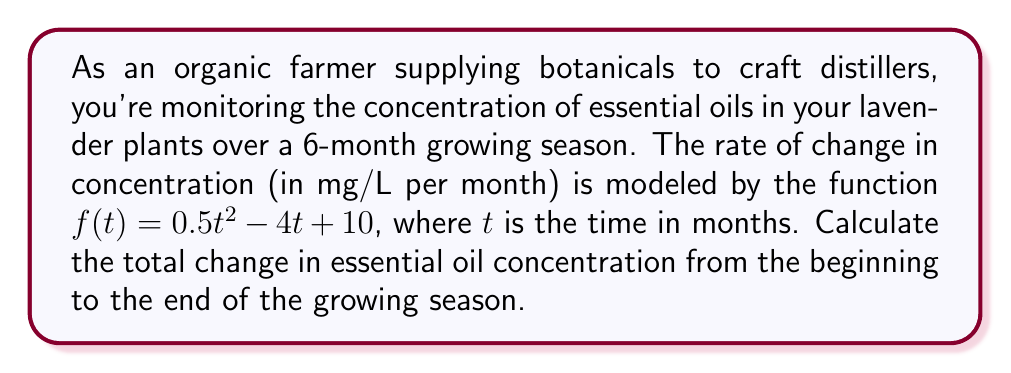Provide a solution to this math problem. To solve this problem, we need to use integral calculus. The steps are as follows:

1) The rate of change in concentration is given by $f(t) = 0.5t^2 - 4t + 10$.

2) To find the total change in concentration, we need to integrate this function over the time period from 0 to 6 months.

3) The integral we need to calculate is:

   $$\int_0^6 (0.5t^2 - 4t + 10) dt$$

4) Let's integrate each term separately:

   $$\int_0^6 0.5t^2 dt = \frac{0.5t^3}{3} \bigg|_0^6$$
   $$\int_0^6 -4t dt = -2t^2 \bigg|_0^6$$
   $$\int_0^6 10 dt = 10t \bigg|_0^6$$

5) Now, let's evaluate each term:

   $$\frac{0.5t^3}{3} \bigg|_0^6 = \frac{0.5(6^3)}{3} - \frac{0.5(0^3)}{3} = 36 - 0 = 36$$
   $$-2t^2 \bigg|_0^6 = -2(6^2) - (-2(0^2)) = -72 - 0 = -72$$
   $$10t \bigg|_0^6 = 10(6) - 10(0) = 60 - 0 = 60$$

6) Sum up all the terms:

   $$36 - 72 + 60 = 24$$

Therefore, the total change in essential oil concentration over the 6-month period is 24 mg/L.
Answer: 24 mg/L 